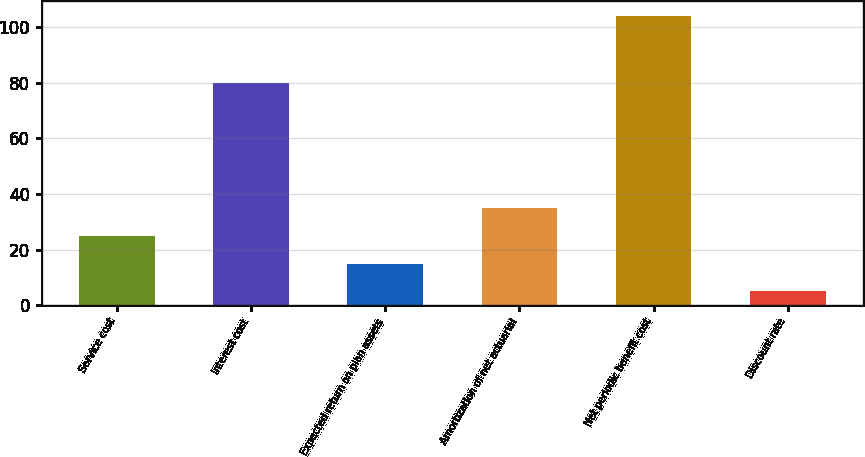<chart> <loc_0><loc_0><loc_500><loc_500><bar_chart><fcel>Service cost<fcel>Interest cost<fcel>Expected return on plan assets<fcel>Amortization of net actuarial<fcel>Net periodic benefit cost<fcel>Discount rate<nl><fcel>24.88<fcel>80<fcel>14.99<fcel>34.77<fcel>104<fcel>5.1<nl></chart> 